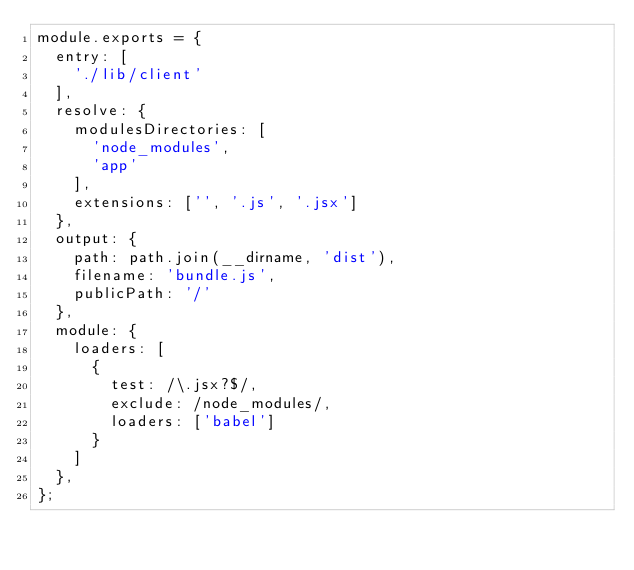<code> <loc_0><loc_0><loc_500><loc_500><_JavaScript_>module.exports = {
  entry: [
    './lib/client'
  ],
  resolve: {
    modulesDirectories: [
      'node_modules',
      'app'
    ],
    extensions: ['', '.js', '.jsx']
  },
  output: {
    path: path.join(__dirname, 'dist'),
    filename: 'bundle.js',
    publicPath: '/'
  },
  module: {
    loaders: [
      {
        test: /\.jsx?$/,
        exclude: /node_modules/,
        loaders: ['babel']
      }
    ]
  },
};
</code> 